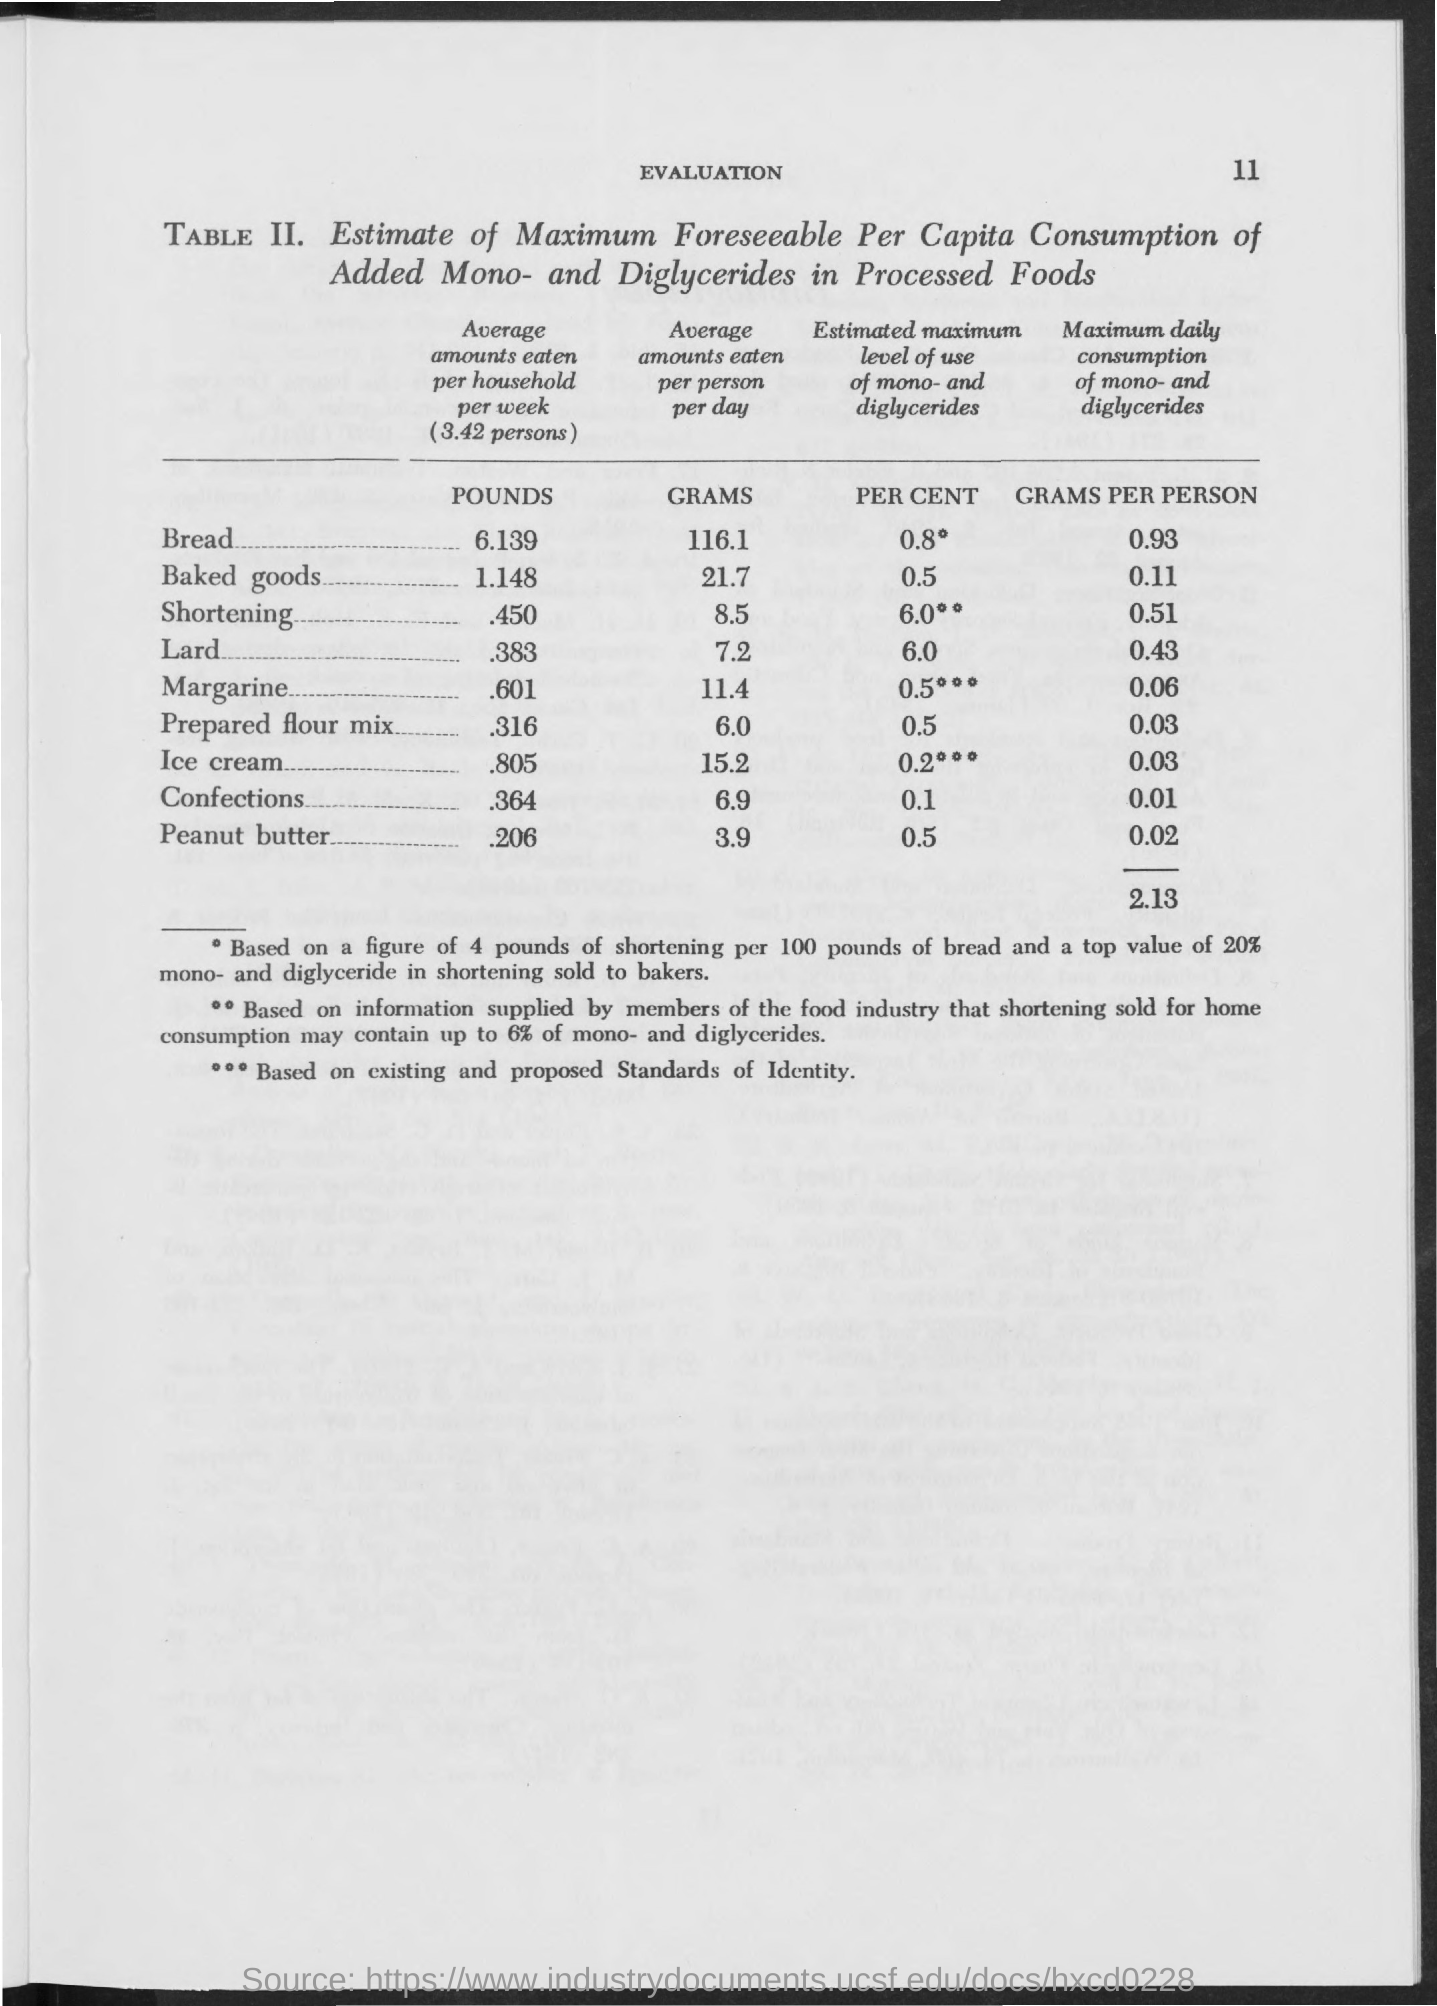What is the first title in the document?
Provide a succinct answer. Evaluation. 